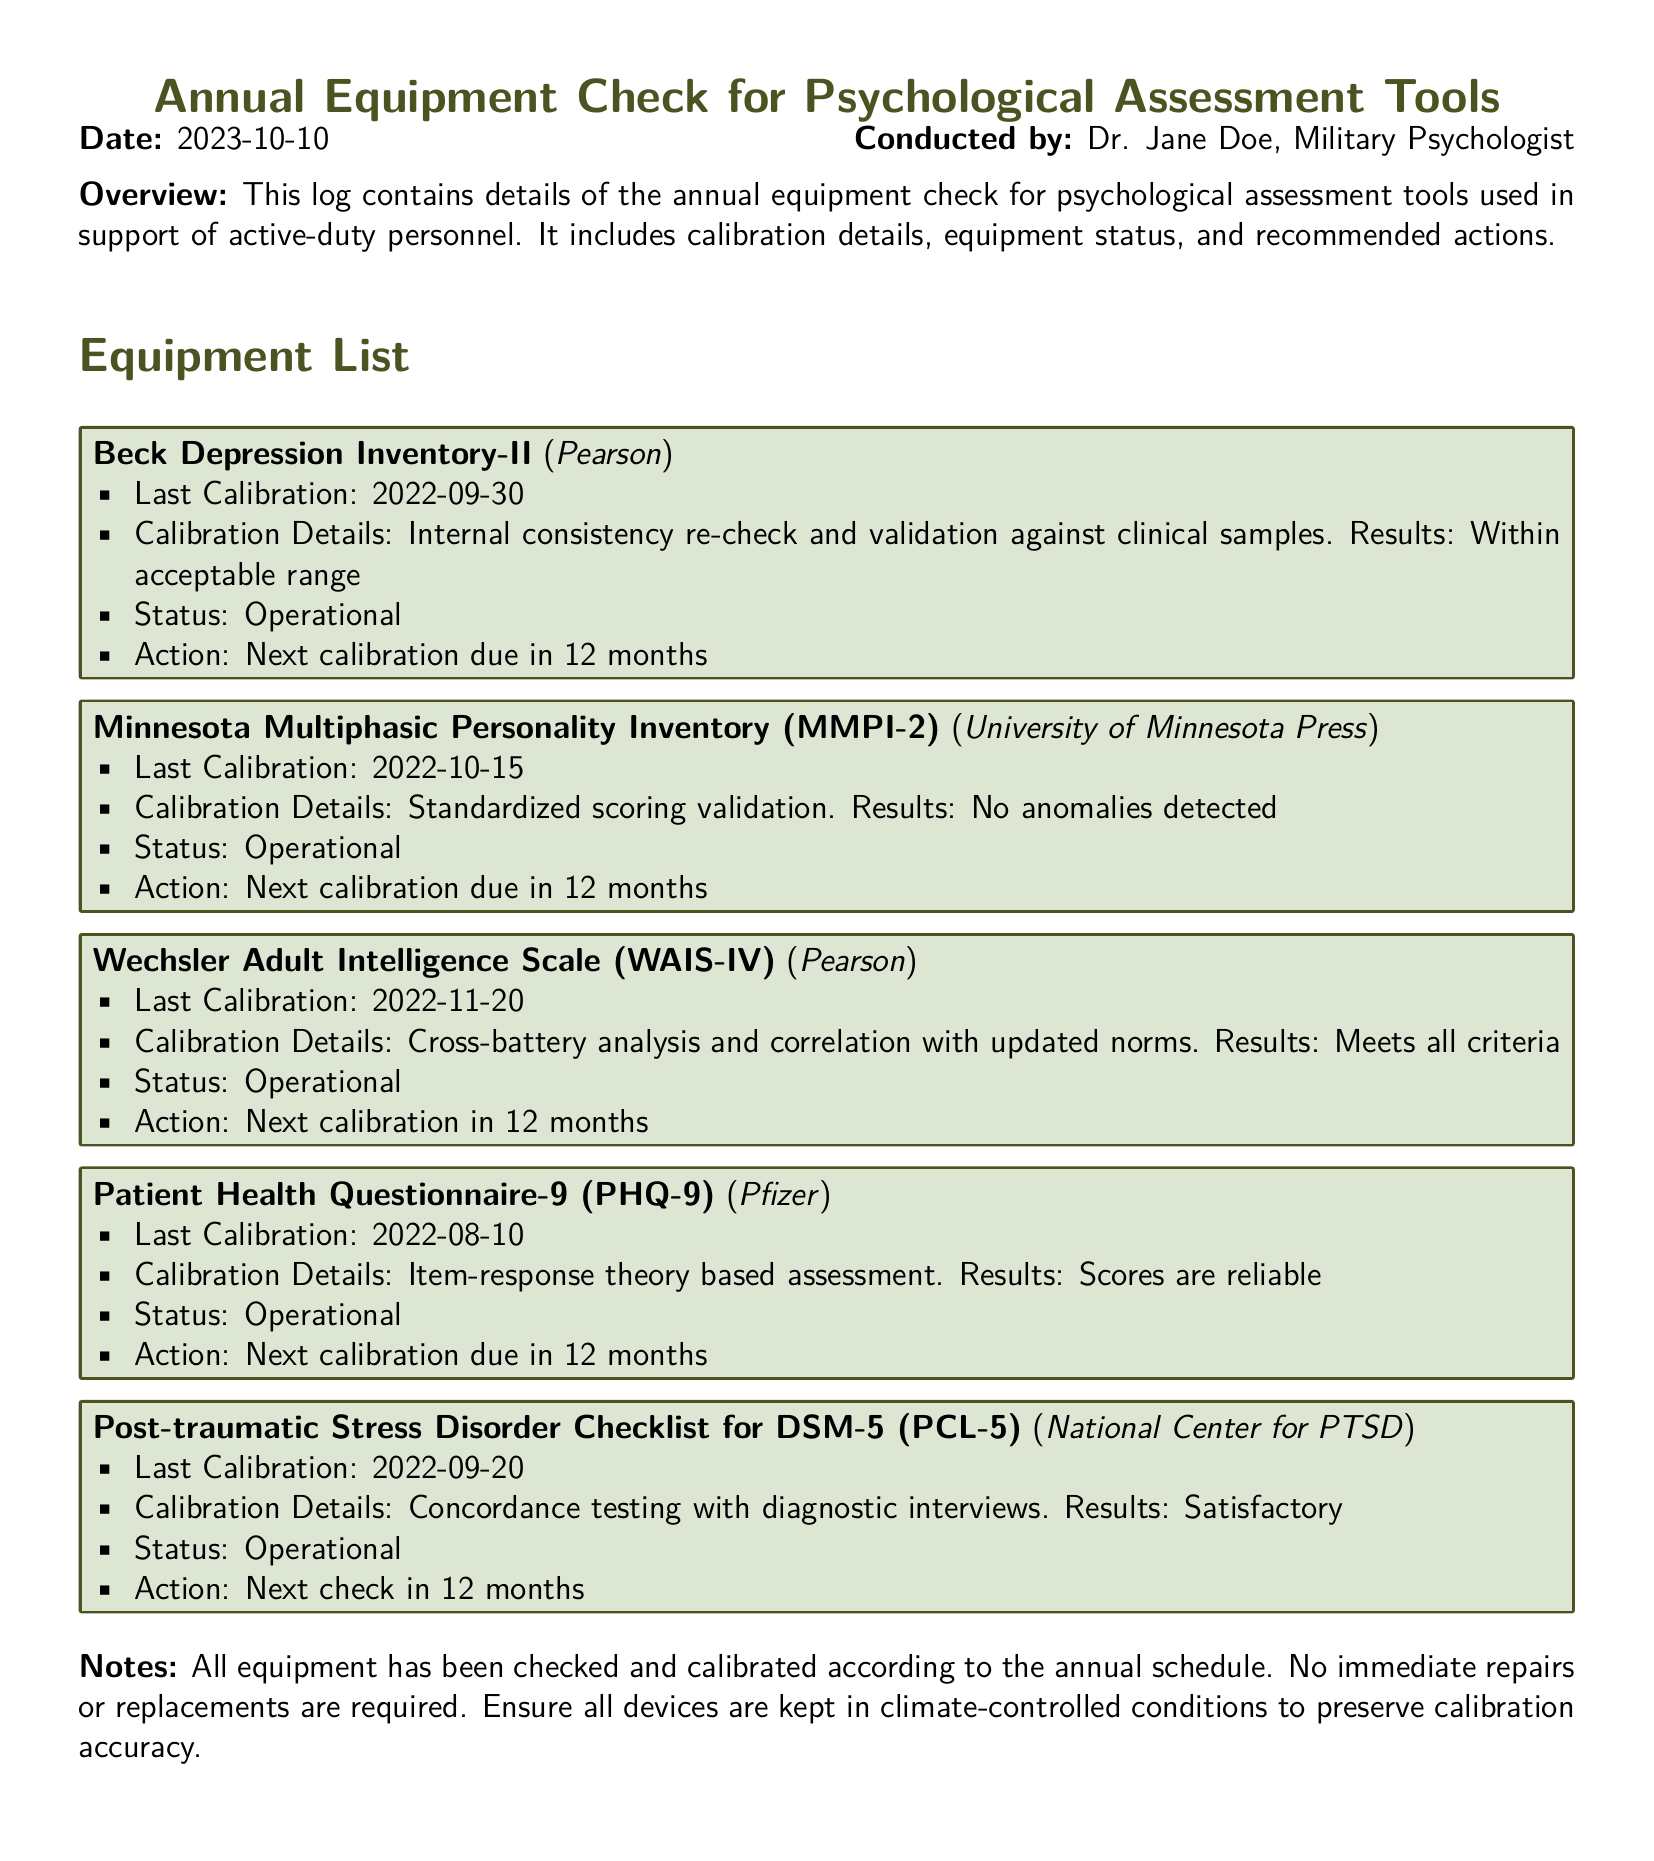What is the date of the equipment check? The date of the equipment check is specified in the document as the date when the log was conducted.
Answer: 2023-10-10 Who conducted the assessment? The name listed in the document as the individual who conducted the assessment provides the relevant information.
Answer: Dr. Jane Doe When is the next calibration due for the Beck Depression Inventory-II? The document states the next calibration date for each equipment item, focusing specifically on the Beck Depression Inventory-II.
Answer: 12 months What organization publishes the MMPI-2? The document identifies the organization responsible for the publication of the MMPI-2 by name.
Answer: University of Minnesota Press What was the result of the calibration check for the WAIS-IV? The result of the calibration check for the WAIS-IV is mentioned in the calibration details section of the document.
Answer: Meets all criteria How many pieces of equipment were checked in total? The document lists the different types of psychological assessment tools that were checked, allowing for counting.
Answer: 5 What action is suggested for all equipment after the check? The document provides a general note regarding the maintenance of all checked equipment.
Answer: Ensure all devices are kept in climate-controlled conditions What is the status of the Patient Health Questionnaire-9? The status is given directly next to the specific equipment listed in the document.
Answer: Operational 